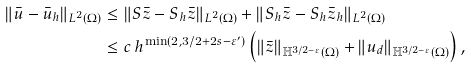Convert formula to latex. <formula><loc_0><loc_0><loc_500><loc_500>\| \bar { u } - \bar { u } _ { h } \| _ { L ^ { 2 } ( \Omega ) } & \leq \| S \bar { z } - S _ { h } \bar { z } \| _ { L ^ { 2 } ( \Omega ) } + \| S _ { h } \bar { z } - S _ { h } \bar { z } _ { h } \| _ { L ^ { 2 } ( \Omega ) } \\ & \leq c \, h ^ { \min ( 2 , 3 / 2 + 2 s - \varepsilon ^ { \prime } ) } \left ( \| \bar { z } \| _ { \mathbb { H } ^ { 3 / 2 - \varepsilon } ( \Omega ) } + \| u _ { d } \| _ { \mathbb { H } ^ { 3 / 2 - \varepsilon } ( \Omega ) } \right ) ,</formula> 